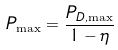<formula> <loc_0><loc_0><loc_500><loc_500>P _ { \max } = \frac { P _ { D , \max } } { 1 - \eta }</formula> 